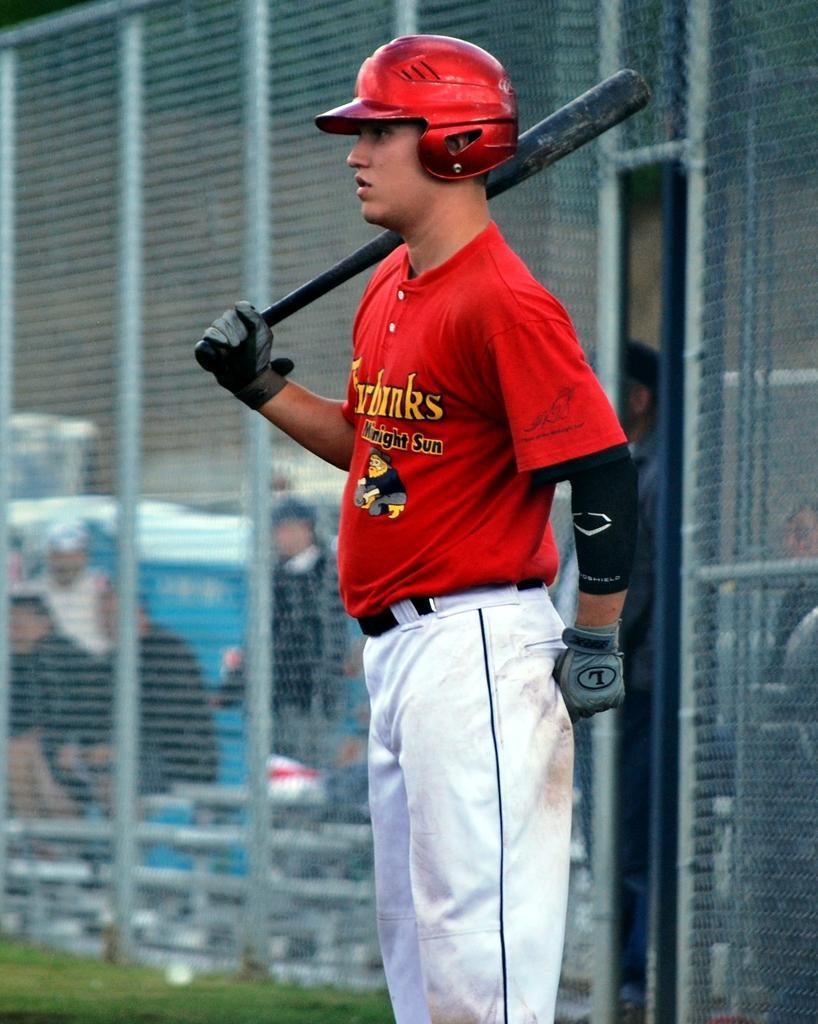How would you summarize this image in a sentence or two? In the image in the center we can see one person standing and he is holding bat. And we can see he is wearing a helmet and red color t shirt. In the background there is a fence,grass,few people standing and few other objects. 